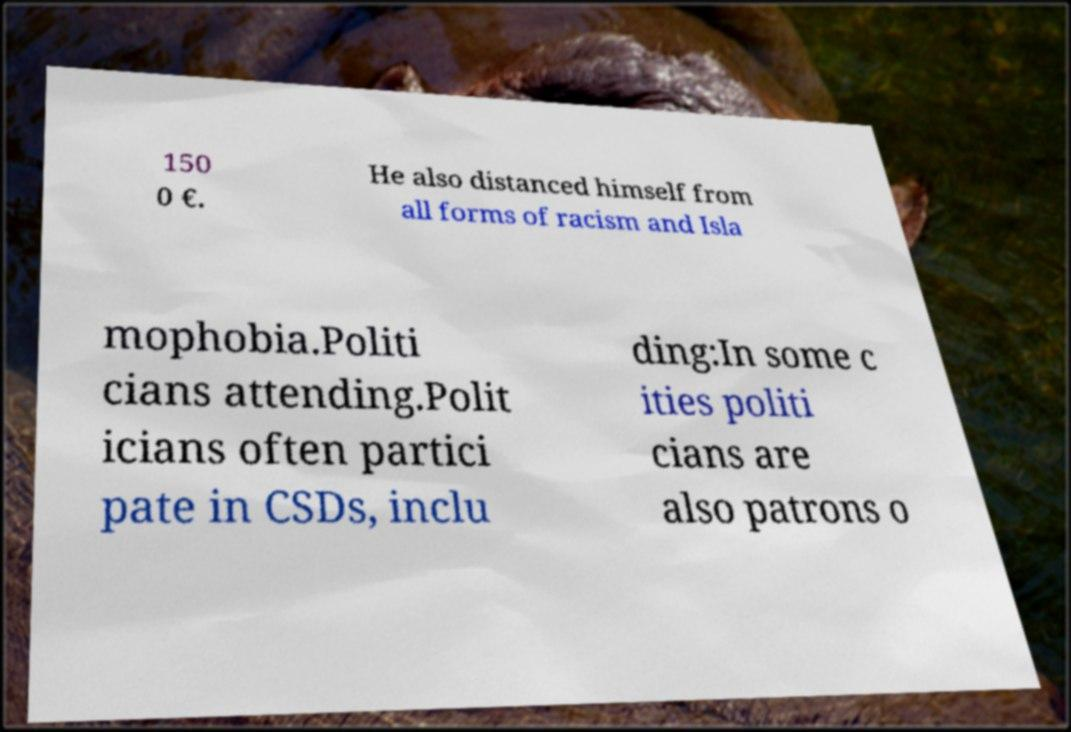I need the written content from this picture converted into text. Can you do that? 150 0 €. He also distanced himself from all forms of racism and Isla mophobia.Politi cians attending.Polit icians often partici pate in CSDs, inclu ding:In some c ities politi cians are also patrons o 